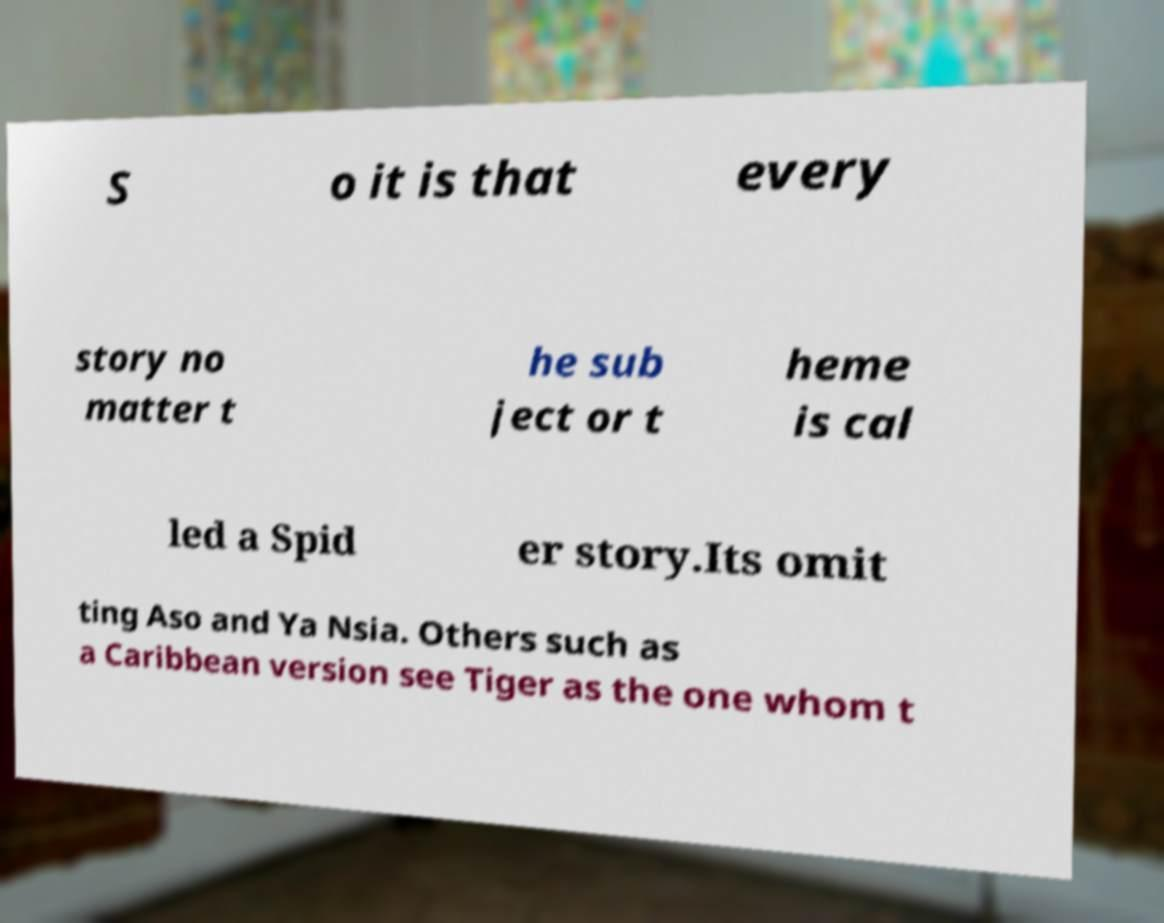Can you read and provide the text displayed in the image?This photo seems to have some interesting text. Can you extract and type it out for me? S o it is that every story no matter t he sub ject or t heme is cal led a Spid er story.Its omit ting Aso and Ya Nsia. Others such as a Caribbean version see Tiger as the one whom t 